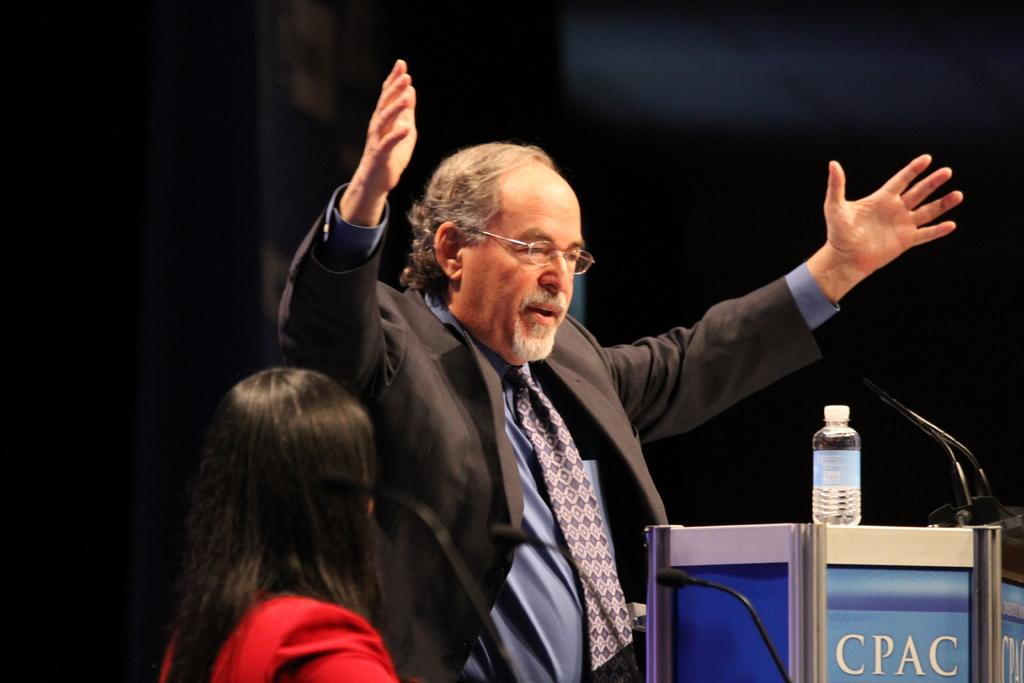<image>
Describe the image concisely. The letters on the blue podium are CPAC 